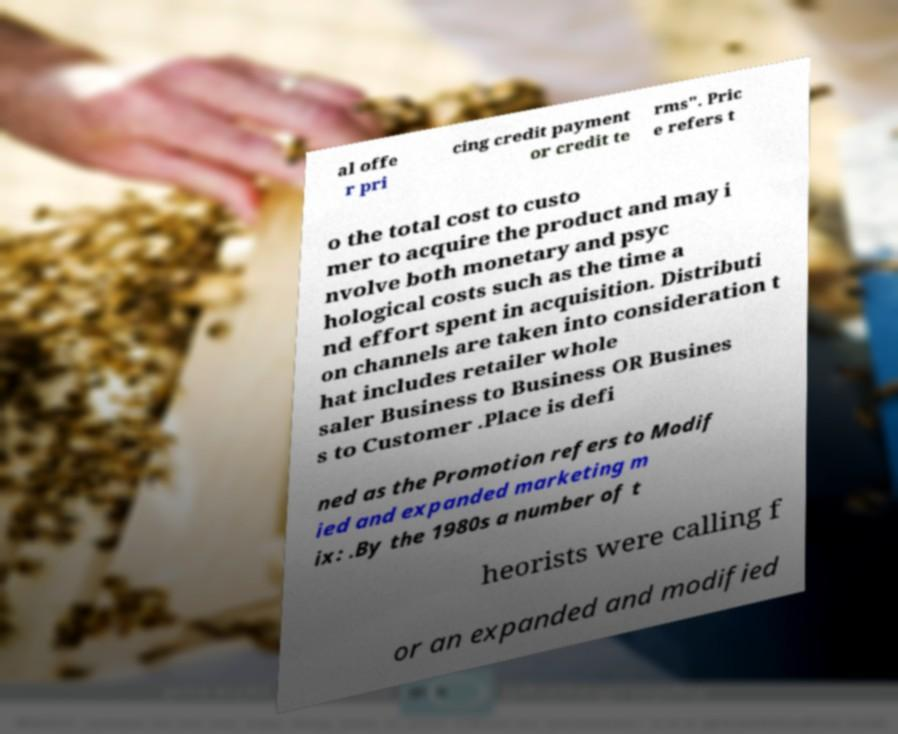Could you extract and type out the text from this image? al offe r pri cing credit payment or credit te rms". Pric e refers t o the total cost to custo mer to acquire the product and may i nvolve both monetary and psyc hological costs such as the time a nd effort spent in acquisition. Distributi on channels are taken into consideration t hat includes retailer whole saler Business to Business OR Busines s to Customer .Place is defi ned as the Promotion refers to Modif ied and expanded marketing m ix: .By the 1980s a number of t heorists were calling f or an expanded and modified 